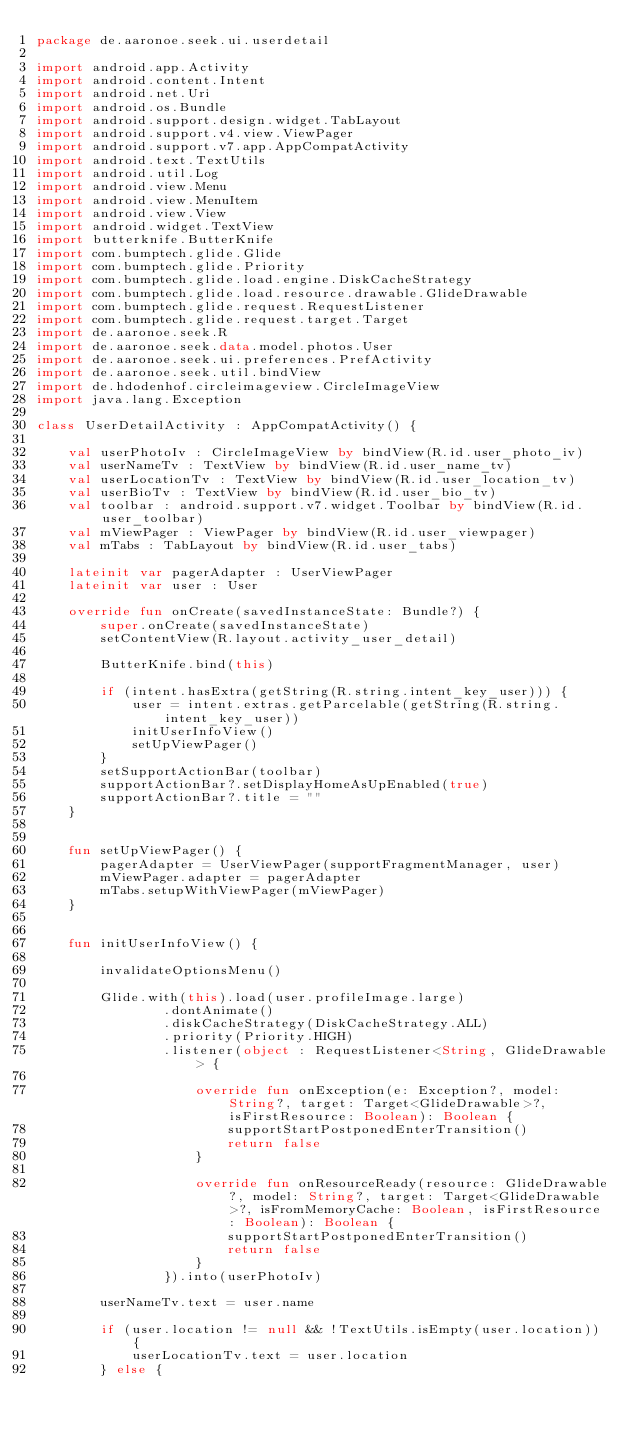<code> <loc_0><loc_0><loc_500><loc_500><_Kotlin_>package de.aaronoe.seek.ui.userdetail

import android.app.Activity
import android.content.Intent
import android.net.Uri
import android.os.Bundle
import android.support.design.widget.TabLayout
import android.support.v4.view.ViewPager
import android.support.v7.app.AppCompatActivity
import android.text.TextUtils
import android.util.Log
import android.view.Menu
import android.view.MenuItem
import android.view.View
import android.widget.TextView
import butterknife.ButterKnife
import com.bumptech.glide.Glide
import com.bumptech.glide.Priority
import com.bumptech.glide.load.engine.DiskCacheStrategy
import com.bumptech.glide.load.resource.drawable.GlideDrawable
import com.bumptech.glide.request.RequestListener
import com.bumptech.glide.request.target.Target
import de.aaronoe.seek.R
import de.aaronoe.seek.data.model.photos.User
import de.aaronoe.seek.ui.preferences.PrefActivity
import de.aaronoe.seek.util.bindView
import de.hdodenhof.circleimageview.CircleImageView
import java.lang.Exception

class UserDetailActivity : AppCompatActivity() {

    val userPhotoIv : CircleImageView by bindView(R.id.user_photo_iv)
    val userNameTv : TextView by bindView(R.id.user_name_tv)
    val userLocationTv : TextView by bindView(R.id.user_location_tv)
    val userBioTv : TextView by bindView(R.id.user_bio_tv)
    val toolbar : android.support.v7.widget.Toolbar by bindView(R.id.user_toolbar)
    val mViewPager : ViewPager by bindView(R.id.user_viewpager)
    val mTabs : TabLayout by bindView(R.id.user_tabs)

    lateinit var pagerAdapter : UserViewPager
    lateinit var user : User

    override fun onCreate(savedInstanceState: Bundle?) {
        super.onCreate(savedInstanceState)
        setContentView(R.layout.activity_user_detail)

        ButterKnife.bind(this)

        if (intent.hasExtra(getString(R.string.intent_key_user))) {
            user = intent.extras.getParcelable(getString(R.string.intent_key_user))
            initUserInfoView()
            setUpViewPager()
        }
        setSupportActionBar(toolbar)
        supportActionBar?.setDisplayHomeAsUpEnabled(true)
        supportActionBar?.title = ""
    }


    fun setUpViewPager() {
        pagerAdapter = UserViewPager(supportFragmentManager, user)
        mViewPager.adapter = pagerAdapter
        mTabs.setupWithViewPager(mViewPager)
    }


    fun initUserInfoView() {

        invalidateOptionsMenu()

        Glide.with(this).load(user.profileImage.large)
                .dontAnimate()
                .diskCacheStrategy(DiskCacheStrategy.ALL)
                .priority(Priority.HIGH)
                .listener(object : RequestListener<String, GlideDrawable> {

                    override fun onException(e: Exception?, model: String?, target: Target<GlideDrawable>?, isFirstResource: Boolean): Boolean {
                        supportStartPostponedEnterTransition()
                        return false
                    }

                    override fun onResourceReady(resource: GlideDrawable?, model: String?, target: Target<GlideDrawable>?, isFromMemoryCache: Boolean, isFirstResource: Boolean): Boolean {
                        supportStartPostponedEnterTransition()
                        return false
                    }
                }).into(userPhotoIv)

        userNameTv.text = user.name

        if (user.location != null && !TextUtils.isEmpty(user.location)) {
            userLocationTv.text = user.location
        } else {</code> 